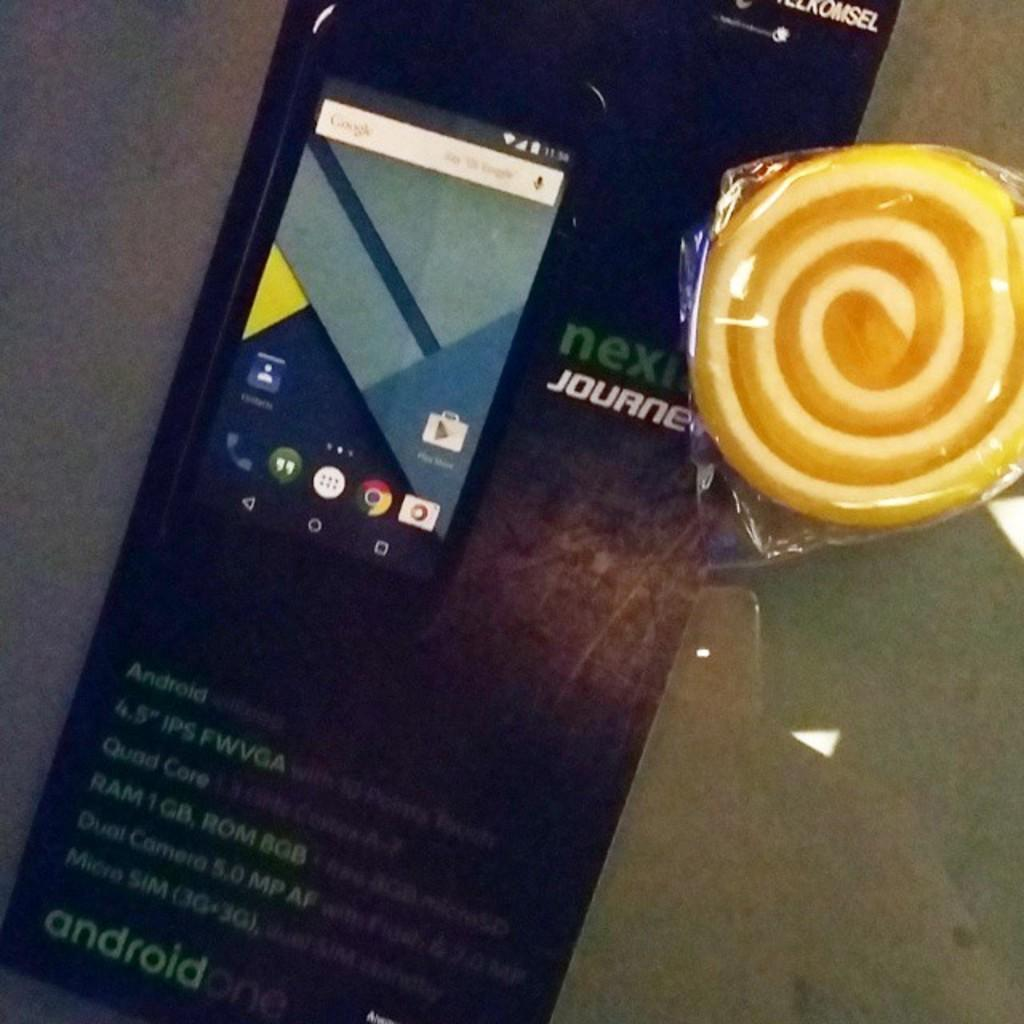<image>
Share a concise interpretation of the image provided. The phone shown is an android one phone. 